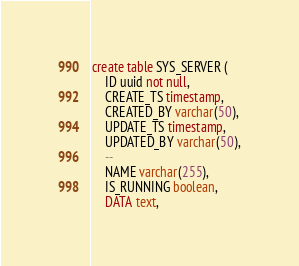Convert code to text. <code><loc_0><loc_0><loc_500><loc_500><_SQL_>create table SYS_SERVER (
    ID uuid not null,
    CREATE_TS timestamp,
    CREATED_BY varchar(50),
    UPDATE_TS timestamp,
    UPDATED_BY varchar(50),
    --
    NAME varchar(255),
    IS_RUNNING boolean,
    DATA text,</code> 